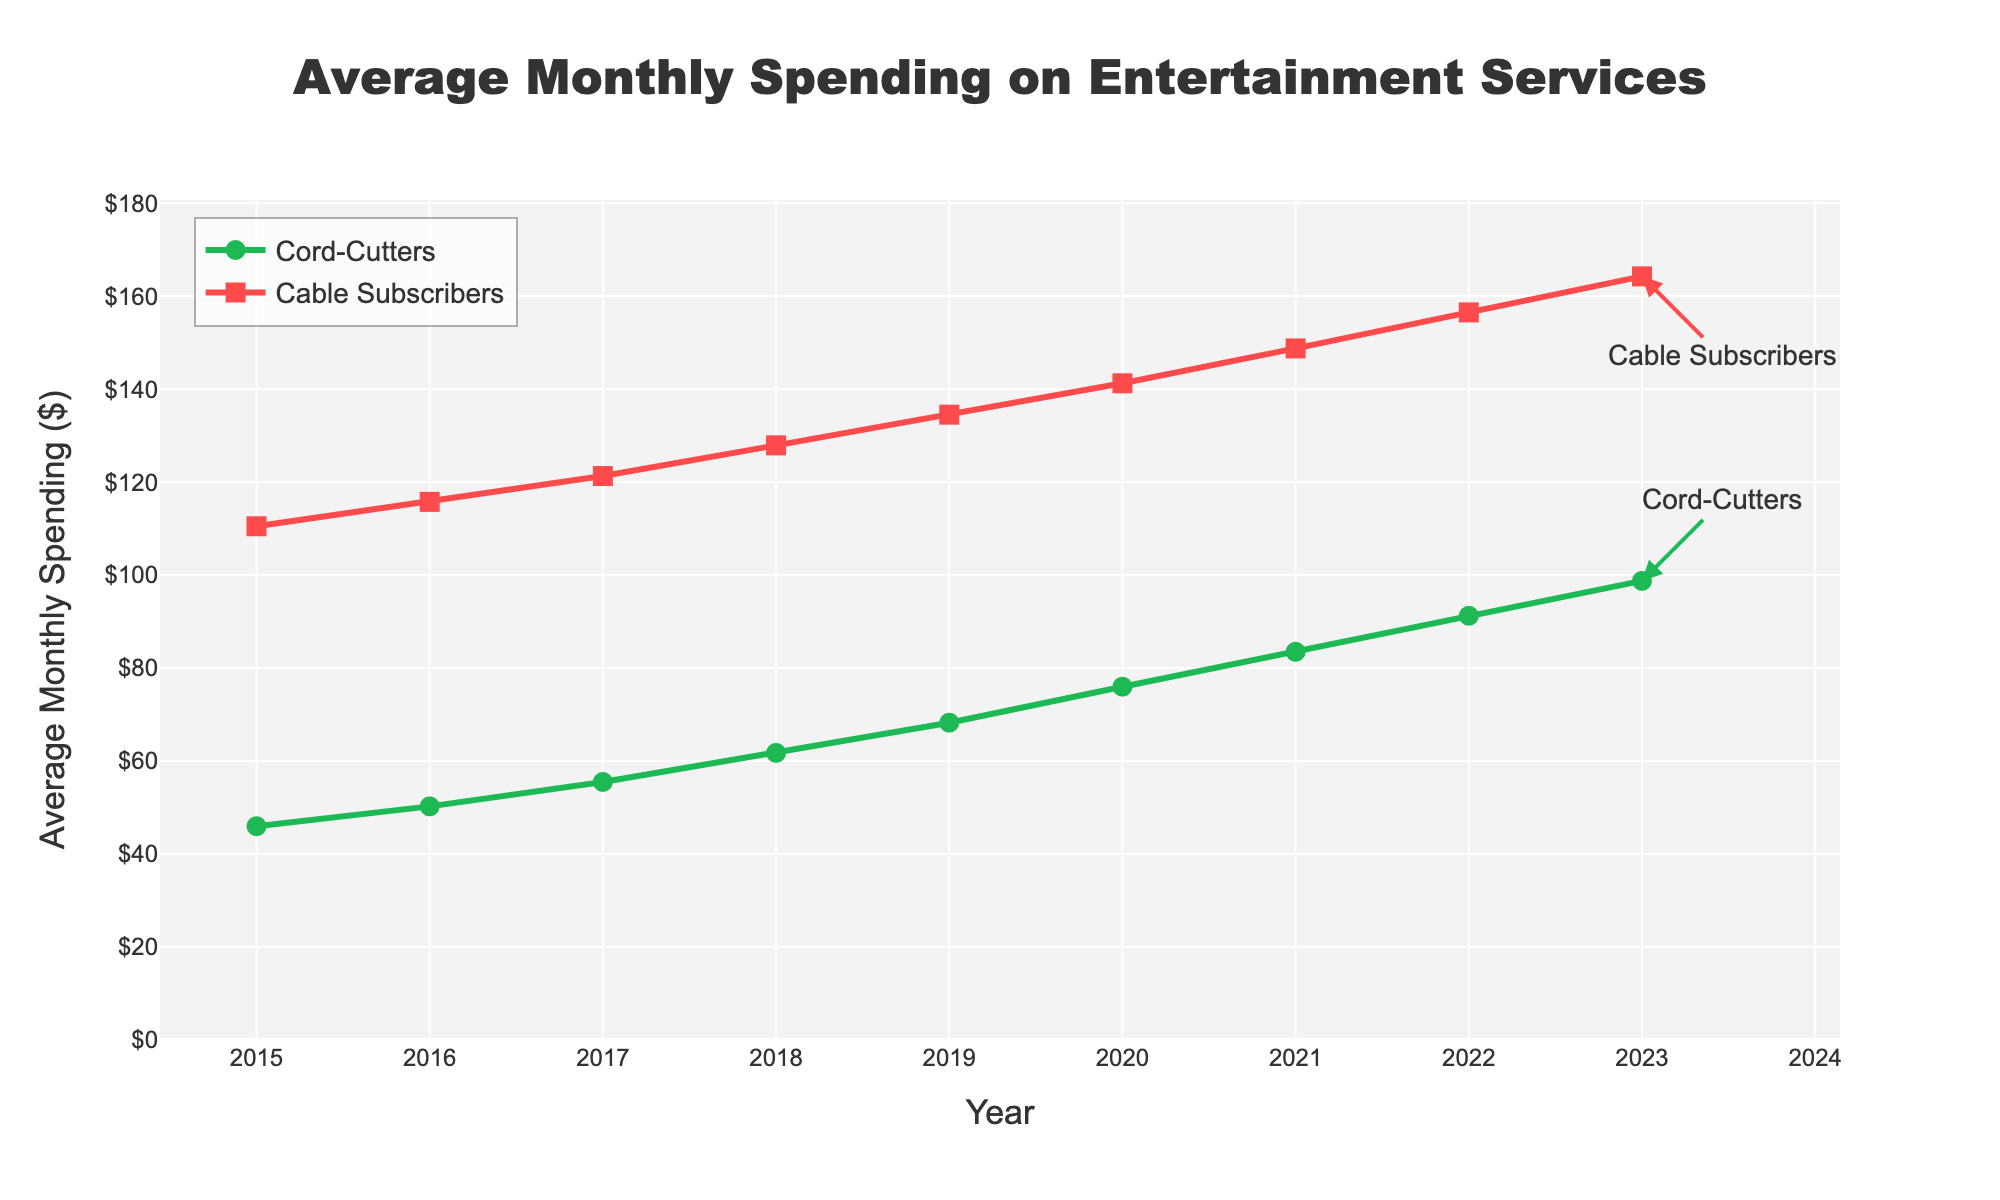What's the average monthly spending on entertainment services for cord-cutters in 2019 and 2023? To find the average monthly spending for cord-cutters in these years, we sum the values for 2019 and 2023 and then divide by 2: (68.25 + 98.75) / 2.
Answer: 83.50 How much more did cable subscribers spend on average per month compared to cord-cutters in 2023? To find the difference, subtract the spending for cord-cutters from the spending for cable subscribers in 2023: 164.25 - 98.75.
Answer: 65.50 What trend can you observe regarding the average monthly spending of cord-cutters and cable subscribers from 2015 to 2023? Observing the slopes of both lines, we notice both spending values are increasing over time, with cable subscribers consistently spending more.
Answer: Increasing trend In which year did cord-cutters spend less than $70 on average per month, but cable subscribers spent more than $130? By examining the line chart, we see that in 2019, cord-cutters spent $68.25, and cable subscribers spent $134.50.
Answer: 2019 What is the total increase in average monthly spending for cord-cutters from 2015 to 2023? Subtract the 2015 value from the 2023 value to find the total increase: 98.75 - 45.99.
Answer: 52.76 Compare the slopes of the lines representing cord-cutters and cable subscribers. Which one has a steeper increase over time? The slope of the line for cable subscribers is consistently steeper compared to the line for cord-cutters, indicating a faster rate of increase in spending.
Answer: Cable subscribers What do the colors of the lines represent in the plot? The green line represents the average monthly spending for cord-cutters, and the red line represents the average monthly spending for cable subscribers.
Answer: Cord-cutters: green, Cable subscribers: red In which year was the difference in spending between cord-cutters and cable subscribers the smallest? By visually inspecting the plot, the smallest gap between the lines appears in 2016. Compute the difference: 115.75 - 50.25.
Answer: 2016 